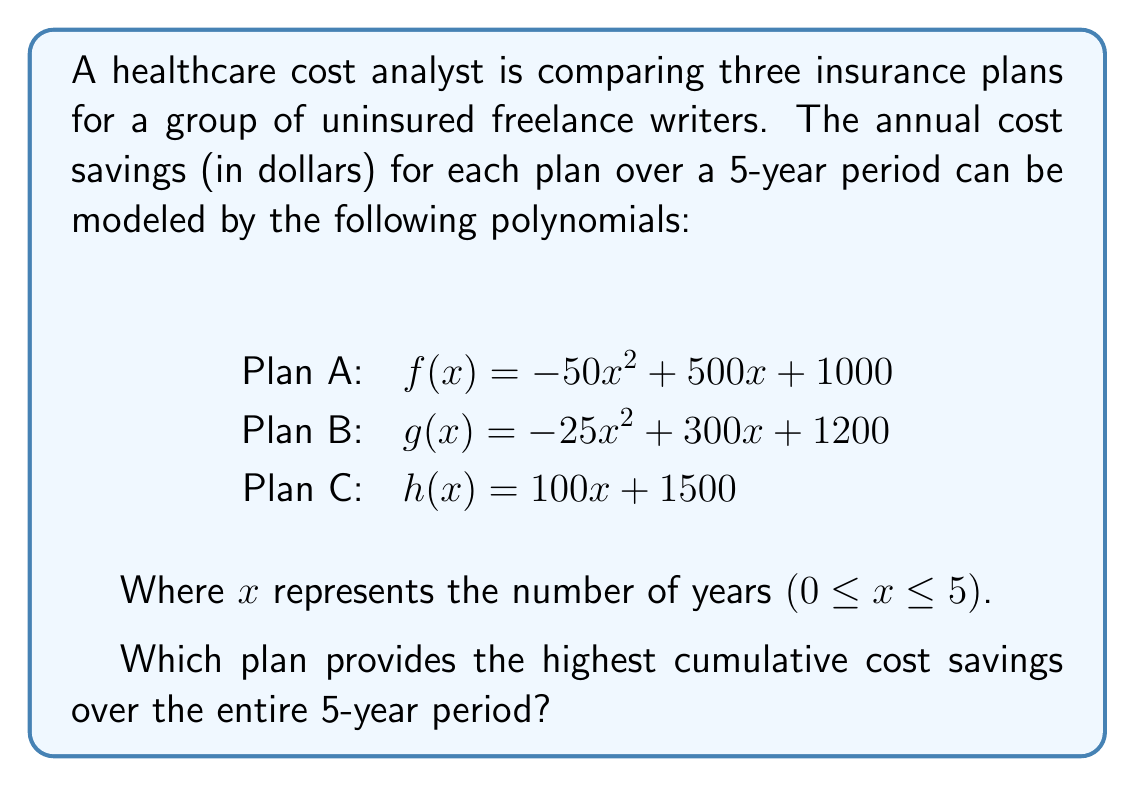Help me with this question. To determine which plan provides the highest cumulative cost savings over the 5-year period, we need to calculate the area under each curve from x = 0 to x = 5.

1. For Plan A: $f(x) = -50x^2 + 500x + 1000$
   Integrate $f(x)$ from 0 to 5:
   $$\int_0^5 (-50x^2 + 500x + 1000) dx = [-\frac{50}{3}x^3 + 250x^2 + 1000x]_0^5$$
   $$= [-\frac{50}{3}(125) + 250(25) + 1000(5)] - [0] = 8333.33 + 6250 + 5000 = 19583.33$$

2. For Plan B: $g(x) = -25x^2 + 300x + 1200$
   Integrate $g(x)$ from 0 to 5:
   $$\int_0^5 (-25x^2 + 300x + 1200) dx = [-\frac{25}{3}x^3 + 150x^2 + 1200x]_0^5$$
   $$= [-\frac{25}{3}(125) + 150(25) + 1200(5)] - [0] = 4166.67 + 3750 + 6000 = 13916.67$$

3. For Plan C: $h(x) = 100x + 1500$
   Integrate $h(x)$ from 0 to 5:
   $$\int_0^5 (100x + 1500) dx = [50x^2 + 1500x]_0^5$$
   $$= [50(25) + 1500(5)] - [0] = 1250 + 7500 = 8750$$

Comparing the results:
Plan A: $19583.33
Plan B: $13916.67
Plan C: $8750

Plan A provides the highest cumulative cost savings over the 5-year period.
Answer: Plan A 